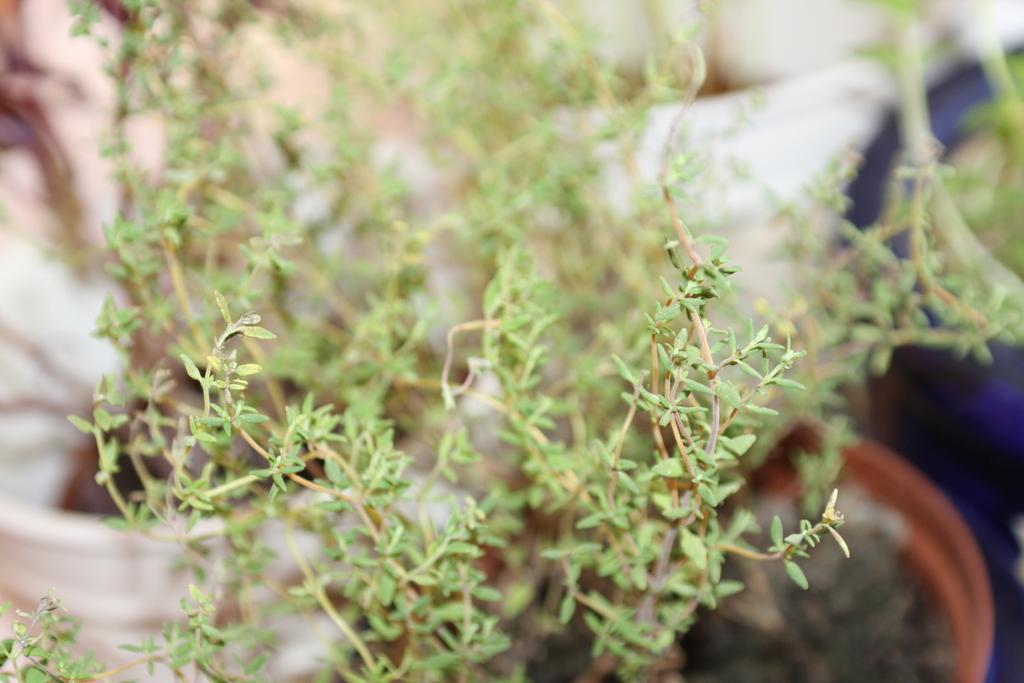Could you give a brief overview of what you see in this image? In this picture we can observe green color plant. On the right side there is a brown color plant pot. In the background there are some white color bags. 